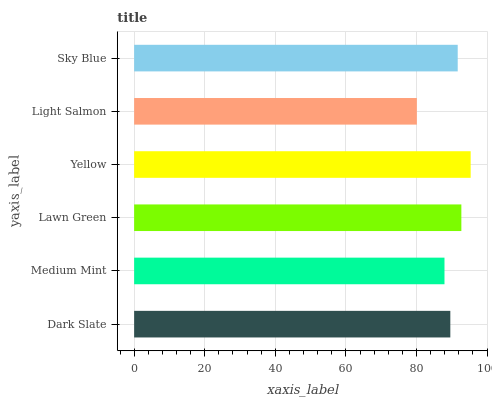Is Light Salmon the minimum?
Answer yes or no. Yes. Is Yellow the maximum?
Answer yes or no. Yes. Is Medium Mint the minimum?
Answer yes or no. No. Is Medium Mint the maximum?
Answer yes or no. No. Is Dark Slate greater than Medium Mint?
Answer yes or no. Yes. Is Medium Mint less than Dark Slate?
Answer yes or no. Yes. Is Medium Mint greater than Dark Slate?
Answer yes or no. No. Is Dark Slate less than Medium Mint?
Answer yes or no. No. Is Sky Blue the high median?
Answer yes or no. Yes. Is Dark Slate the low median?
Answer yes or no. Yes. Is Lawn Green the high median?
Answer yes or no. No. Is Lawn Green the low median?
Answer yes or no. No. 